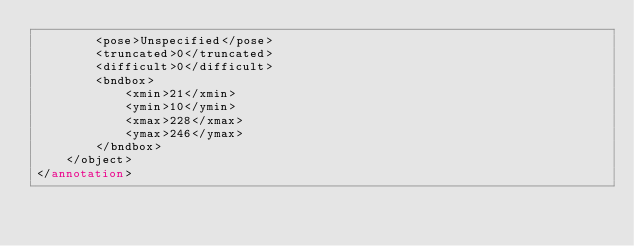<code> <loc_0><loc_0><loc_500><loc_500><_XML_>		<pose>Unspecified</pose>
		<truncated>0</truncated>
		<difficult>0</difficult>
		<bndbox>
			<xmin>21</xmin>
			<ymin>10</ymin>
			<xmax>228</xmax>
			<ymax>246</ymax>
		</bndbox>
	</object>
</annotation>
</code> 